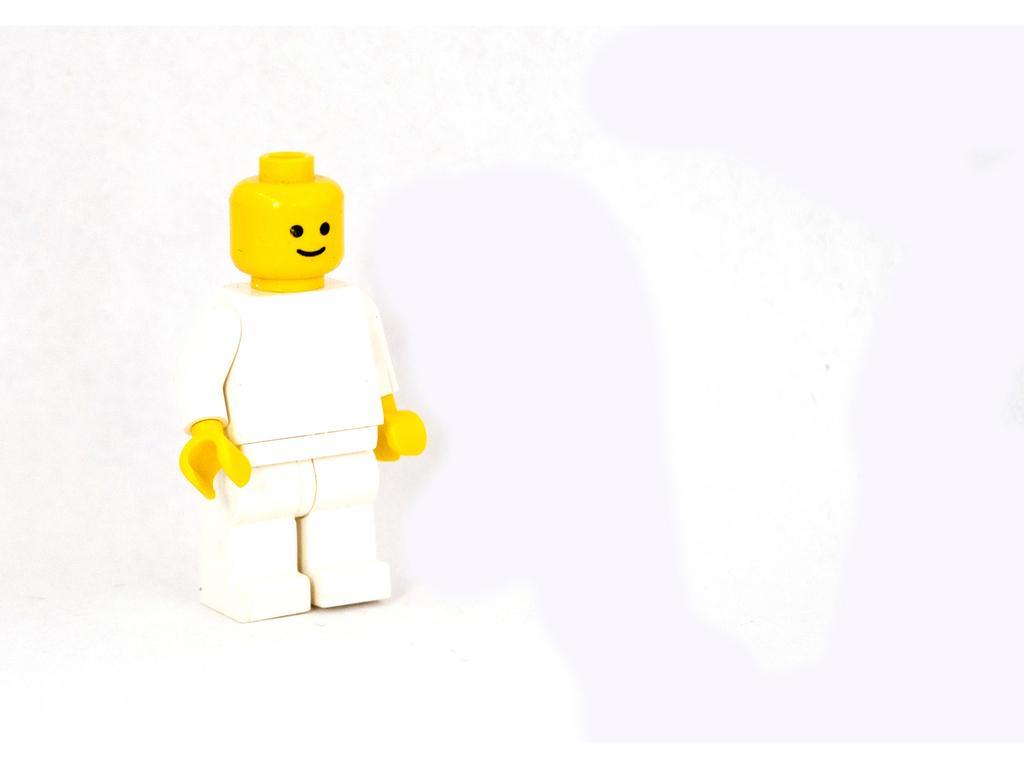In one or two sentences, can you explain what this image depicts? In this image I can see a toy which is white, yellow and black in color. I can see the black colored background. 